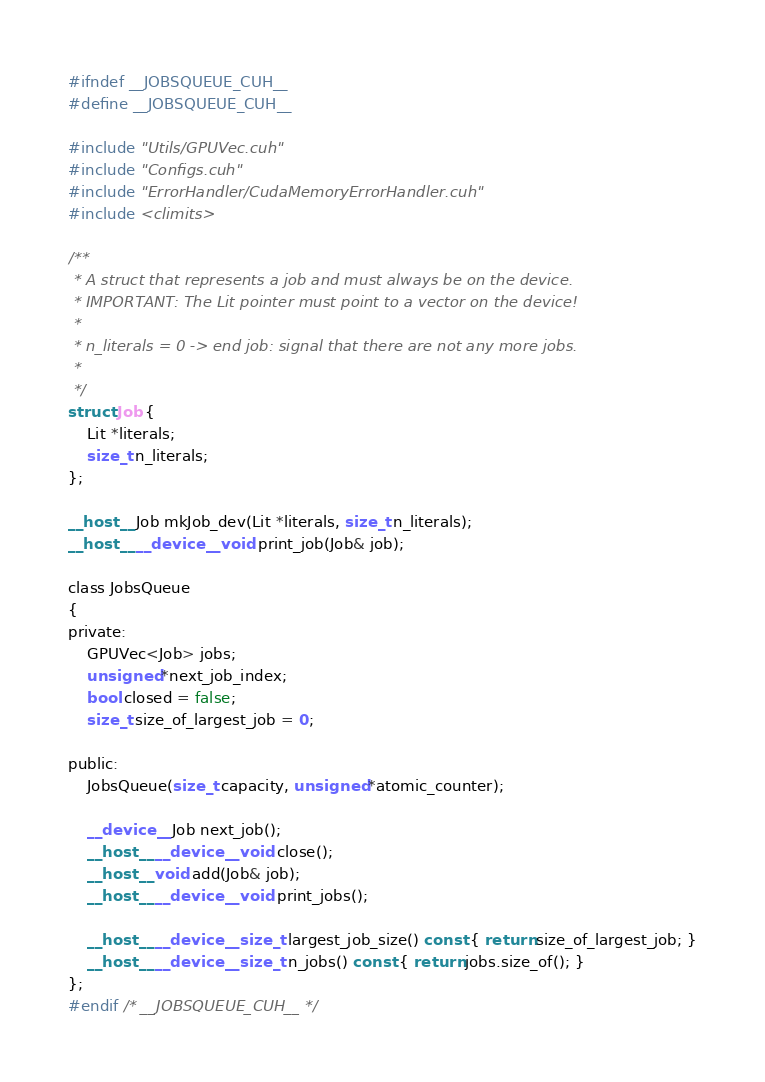Convert code to text. <code><loc_0><loc_0><loc_500><loc_500><_Cuda_>#ifndef __JOBSQUEUE_CUH__
#define __JOBSQUEUE_CUH__

#include "Utils/GPUVec.cuh"
#include "Configs.cuh"
#include "ErrorHandler/CudaMemoryErrorHandler.cuh"
#include <climits>

/**
 * A struct that represents a job and must always be on the device.
 * IMPORTANT: The Lit pointer must point to a vector on the device!
 *
 * n_literals = 0 -> end job: signal that there are not any more jobs.
 *
 */
struct Job {
    Lit *literals;
    size_t n_literals;
};

__host__ Job mkJob_dev(Lit *literals, size_t n_literals);
__host__ __device__ void print_job(Job& job);

class JobsQueue
{
private:
    GPUVec<Job> jobs;
    unsigned *next_job_index;
    bool closed = false;
    size_t size_of_largest_job = 0;

public:
    JobsQueue(size_t capacity, unsigned *atomic_counter);

    __device__ Job next_job();
    __host__ __device__ void close();
    __host__ void add(Job& job);
    __host__ __device__ void print_jobs();

    __host__ __device__ size_t largest_job_size() const { return size_of_largest_job; }
    __host__ __device__ size_t n_jobs() const { return jobs.size_of(); }
};
#endif /* __JOBSQUEUE_CUH__ */

</code> 